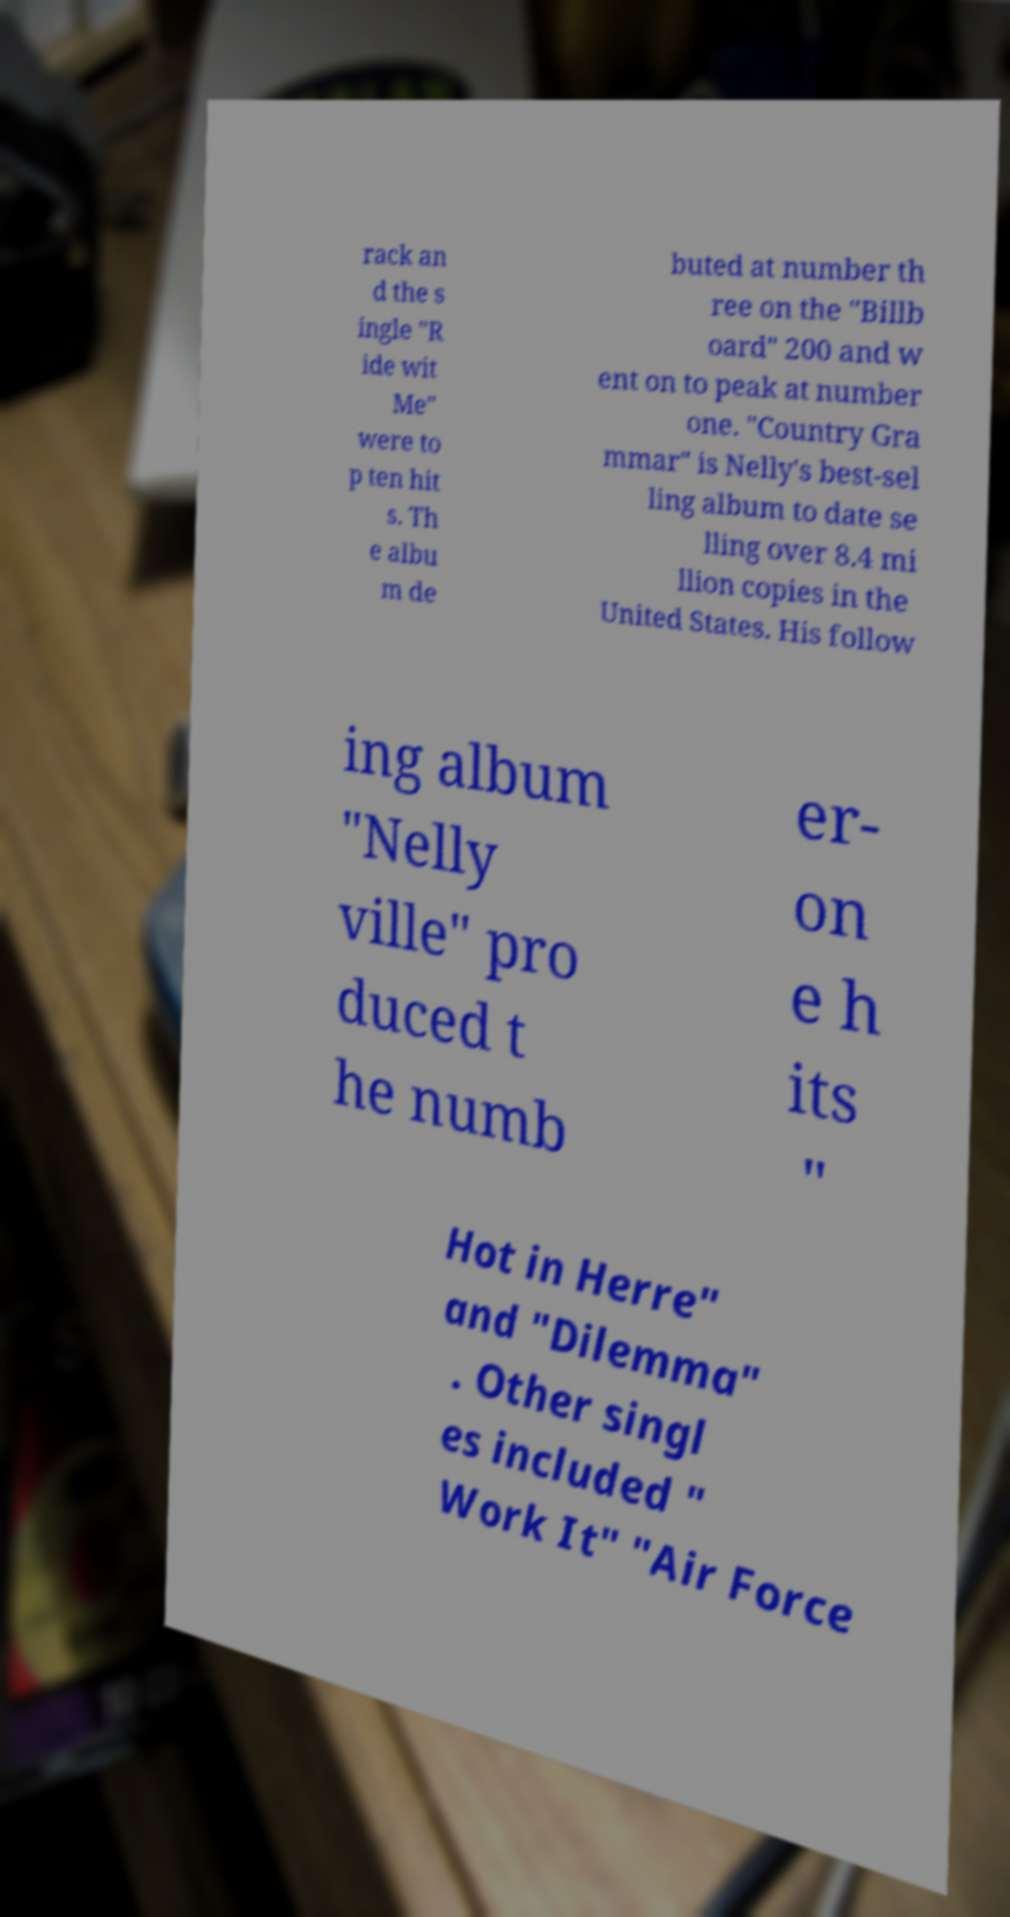Please read and relay the text visible in this image. What does it say? rack an d the s ingle "R ide wit Me" were to p ten hit s. Th e albu m de buted at number th ree on the "Billb oard" 200 and w ent on to peak at number one. "Country Gra mmar" is Nelly's best-sel ling album to date se lling over 8.4 mi llion copies in the United States. His follow ing album "Nelly ville" pro duced t he numb er- on e h its " Hot in Herre" and "Dilemma" . Other singl es included " Work It" "Air Force 